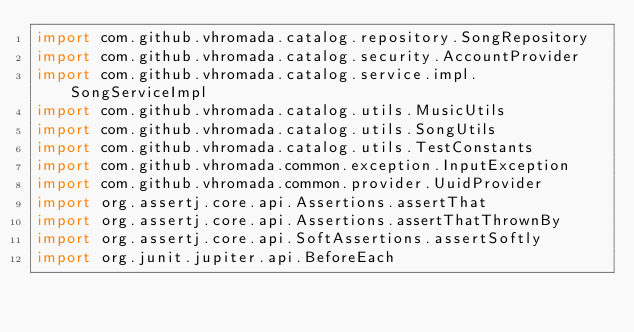Convert code to text. <code><loc_0><loc_0><loc_500><loc_500><_Kotlin_>import com.github.vhromada.catalog.repository.SongRepository
import com.github.vhromada.catalog.security.AccountProvider
import com.github.vhromada.catalog.service.impl.SongServiceImpl
import com.github.vhromada.catalog.utils.MusicUtils
import com.github.vhromada.catalog.utils.SongUtils
import com.github.vhromada.catalog.utils.TestConstants
import com.github.vhromada.common.exception.InputException
import com.github.vhromada.common.provider.UuidProvider
import org.assertj.core.api.Assertions.assertThat
import org.assertj.core.api.Assertions.assertThatThrownBy
import org.assertj.core.api.SoftAssertions.assertSoftly
import org.junit.jupiter.api.BeforeEach</code> 